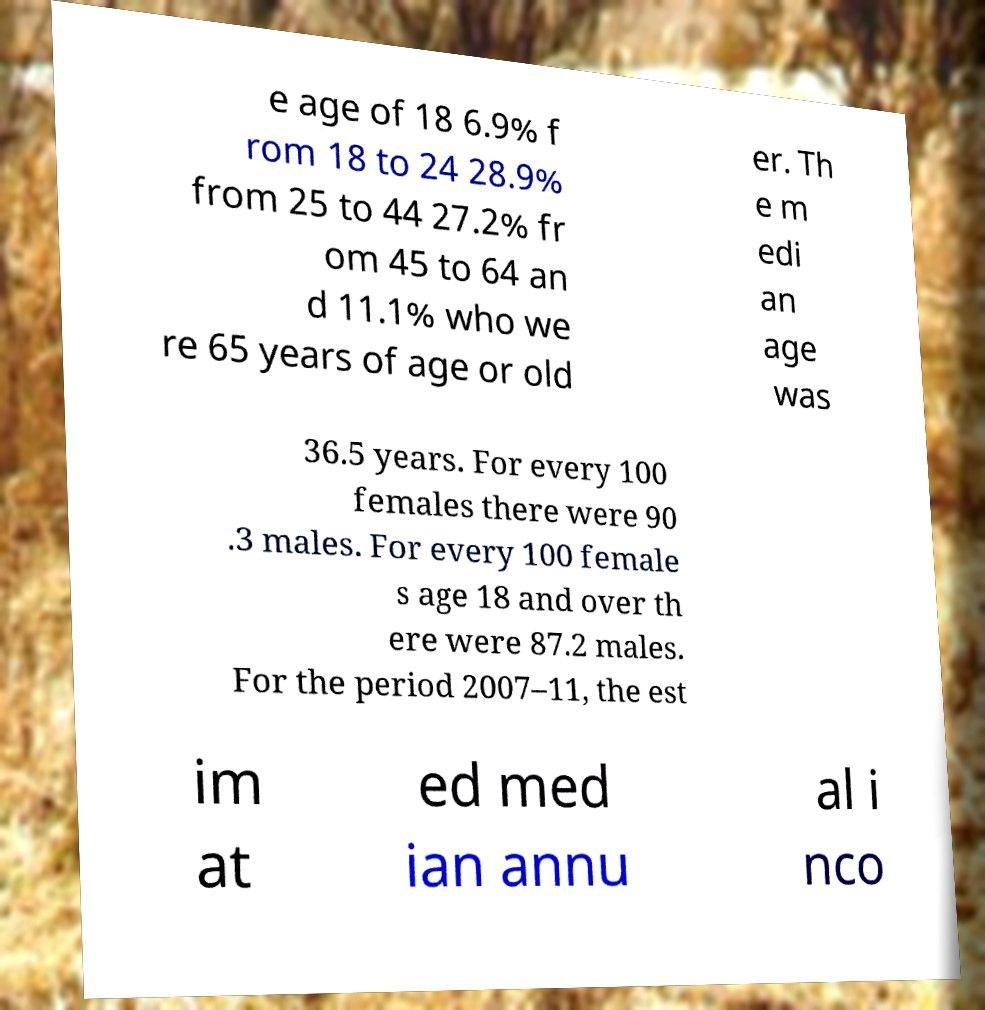Can you read and provide the text displayed in the image?This photo seems to have some interesting text. Can you extract and type it out for me? e age of 18 6.9% f rom 18 to 24 28.9% from 25 to 44 27.2% fr om 45 to 64 an d 11.1% who we re 65 years of age or old er. Th e m edi an age was 36.5 years. For every 100 females there were 90 .3 males. For every 100 female s age 18 and over th ere were 87.2 males. For the period 2007–11, the est im at ed med ian annu al i nco 